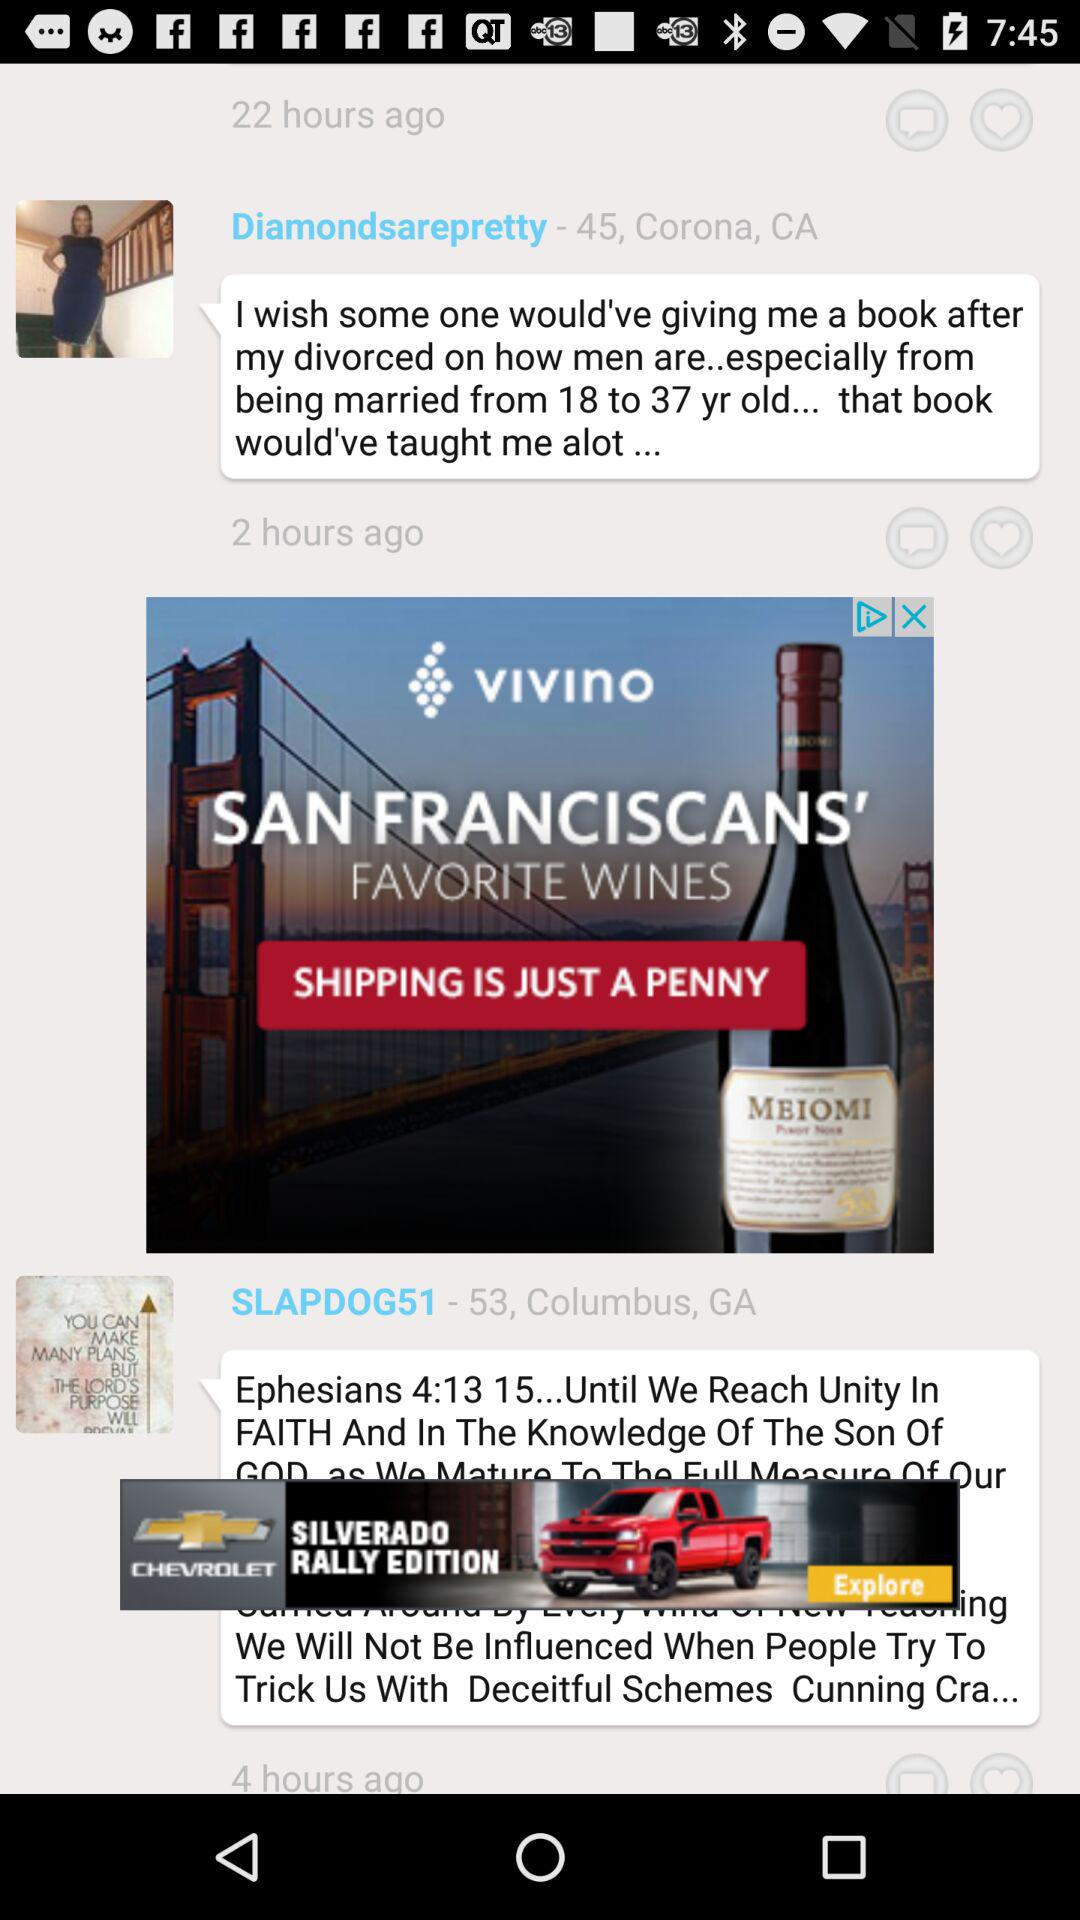How many hours ago did "SLAPDOG51" post? "SLAPDOG51" posted 4 hours ago. 